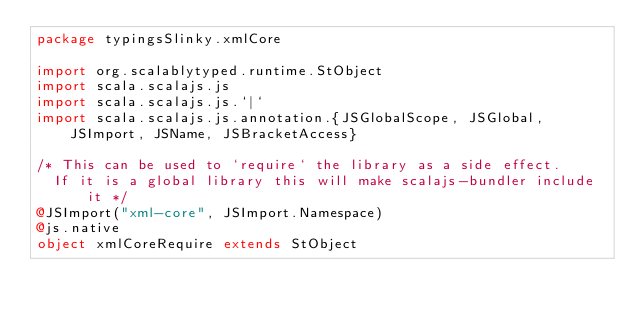<code> <loc_0><loc_0><loc_500><loc_500><_Scala_>package typingsSlinky.xmlCore

import org.scalablytyped.runtime.StObject
import scala.scalajs.js
import scala.scalajs.js.`|`
import scala.scalajs.js.annotation.{JSGlobalScope, JSGlobal, JSImport, JSName, JSBracketAccess}

/* This can be used to `require` the library as a side effect.
  If it is a global library this will make scalajs-bundler include it */
@JSImport("xml-core", JSImport.Namespace)
@js.native
object xmlCoreRequire extends StObject
</code> 